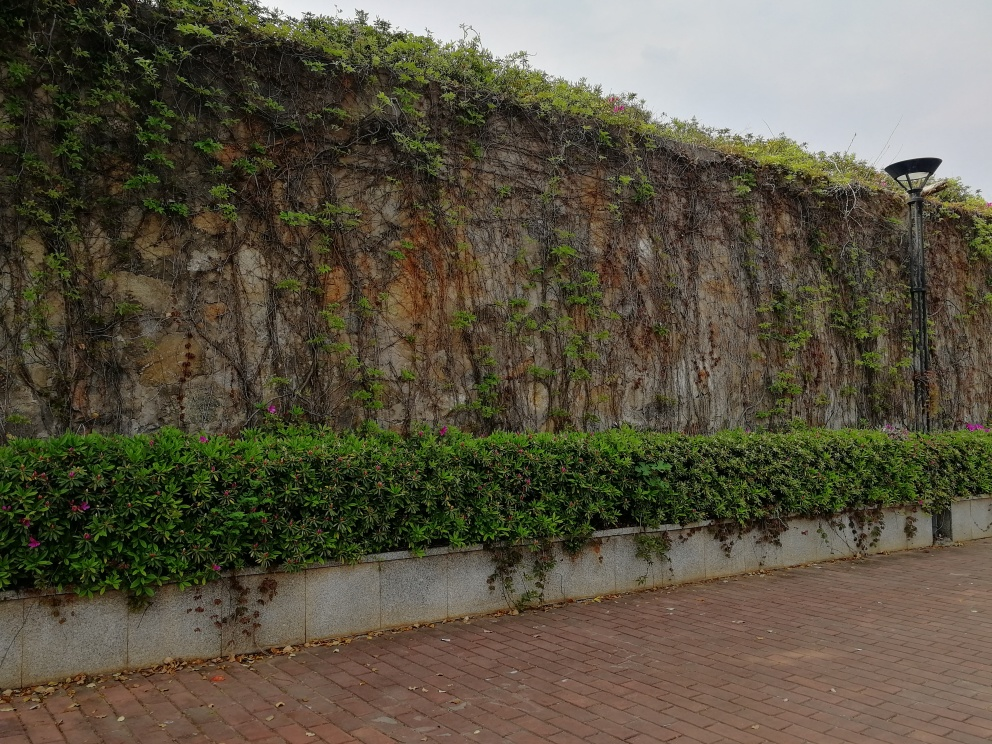Can you tell me about the varieties of plants visible in the image? In the image, you can see a lush array of vegetation with several types of plants. There's a hedge at the bottom with dense, dark green leaves, likely a shrub species suited for trimming. Above the hedge, the wall is draped with climbing plants and vines, displaying a mix of green tones and leaf shapes. Some flowers are noticeable too, introducing spots of color amidst the greenery. 